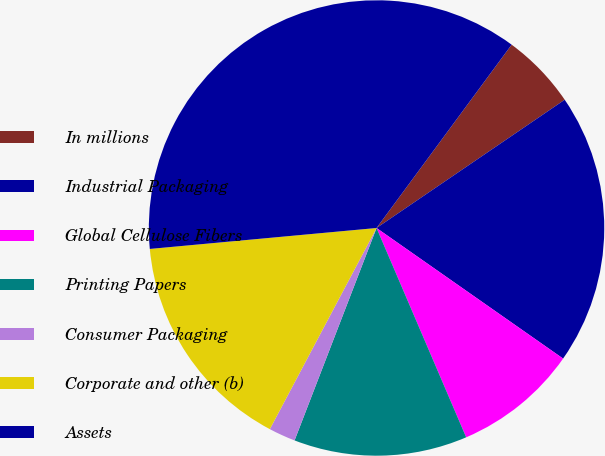Convert chart. <chart><loc_0><loc_0><loc_500><loc_500><pie_chart><fcel>In millions<fcel>Industrial Packaging<fcel>Global Cellulose Fibers<fcel>Printing Papers<fcel>Consumer Packaging<fcel>Corporate and other (b)<fcel>Assets<nl><fcel>5.37%<fcel>19.24%<fcel>8.84%<fcel>12.3%<fcel>1.9%<fcel>15.77%<fcel>36.57%<nl></chart> 